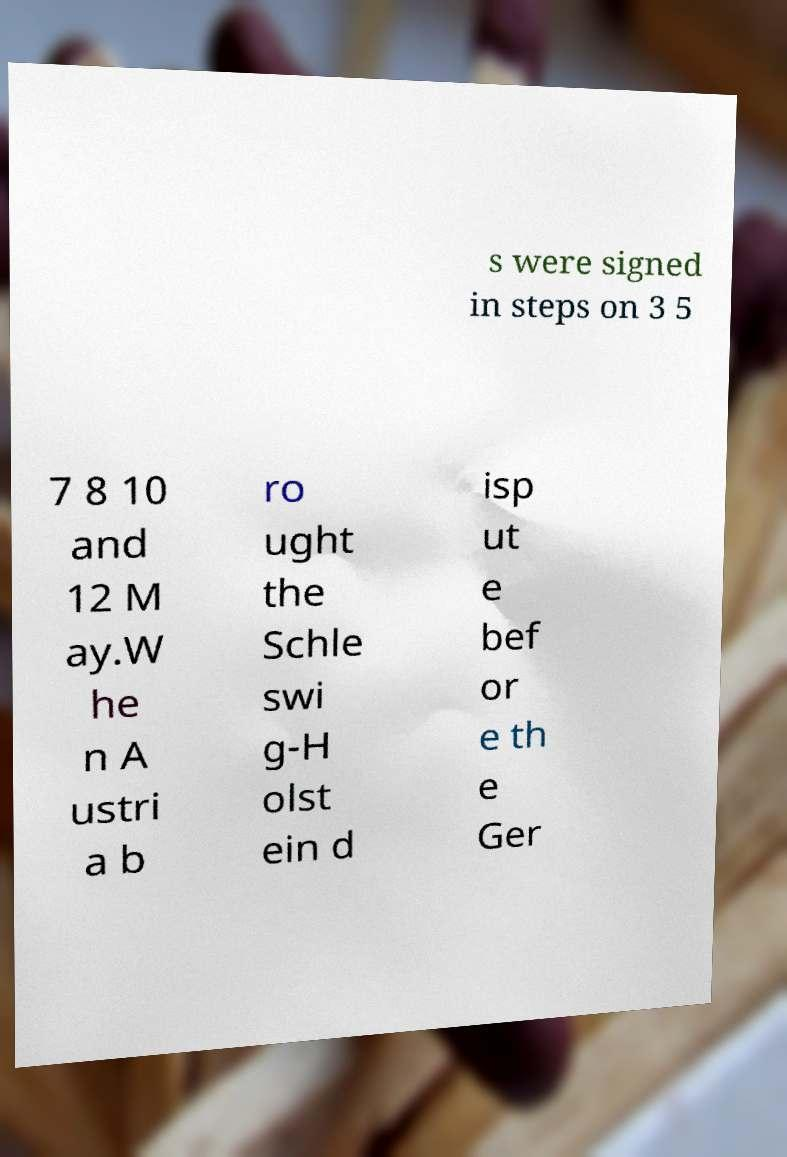Can you read and provide the text displayed in the image?This photo seems to have some interesting text. Can you extract and type it out for me? s were signed in steps on 3 5 7 8 10 and 12 M ay.W he n A ustri a b ro ught the Schle swi g-H olst ein d isp ut e bef or e th e Ger 